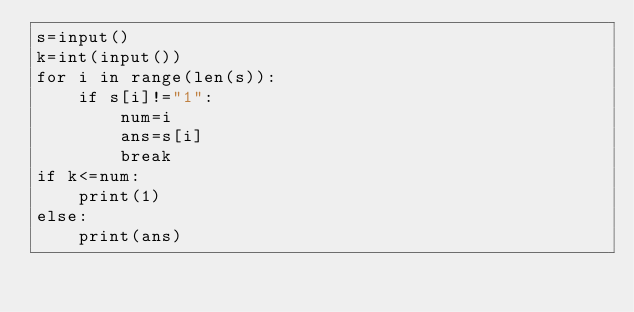<code> <loc_0><loc_0><loc_500><loc_500><_Python_>s=input()
k=int(input())
for i in range(len(s)):
    if s[i]!="1":
        num=i
        ans=s[i]
        break
if k<=num:
    print(1)
else:
    print(ans)
</code> 